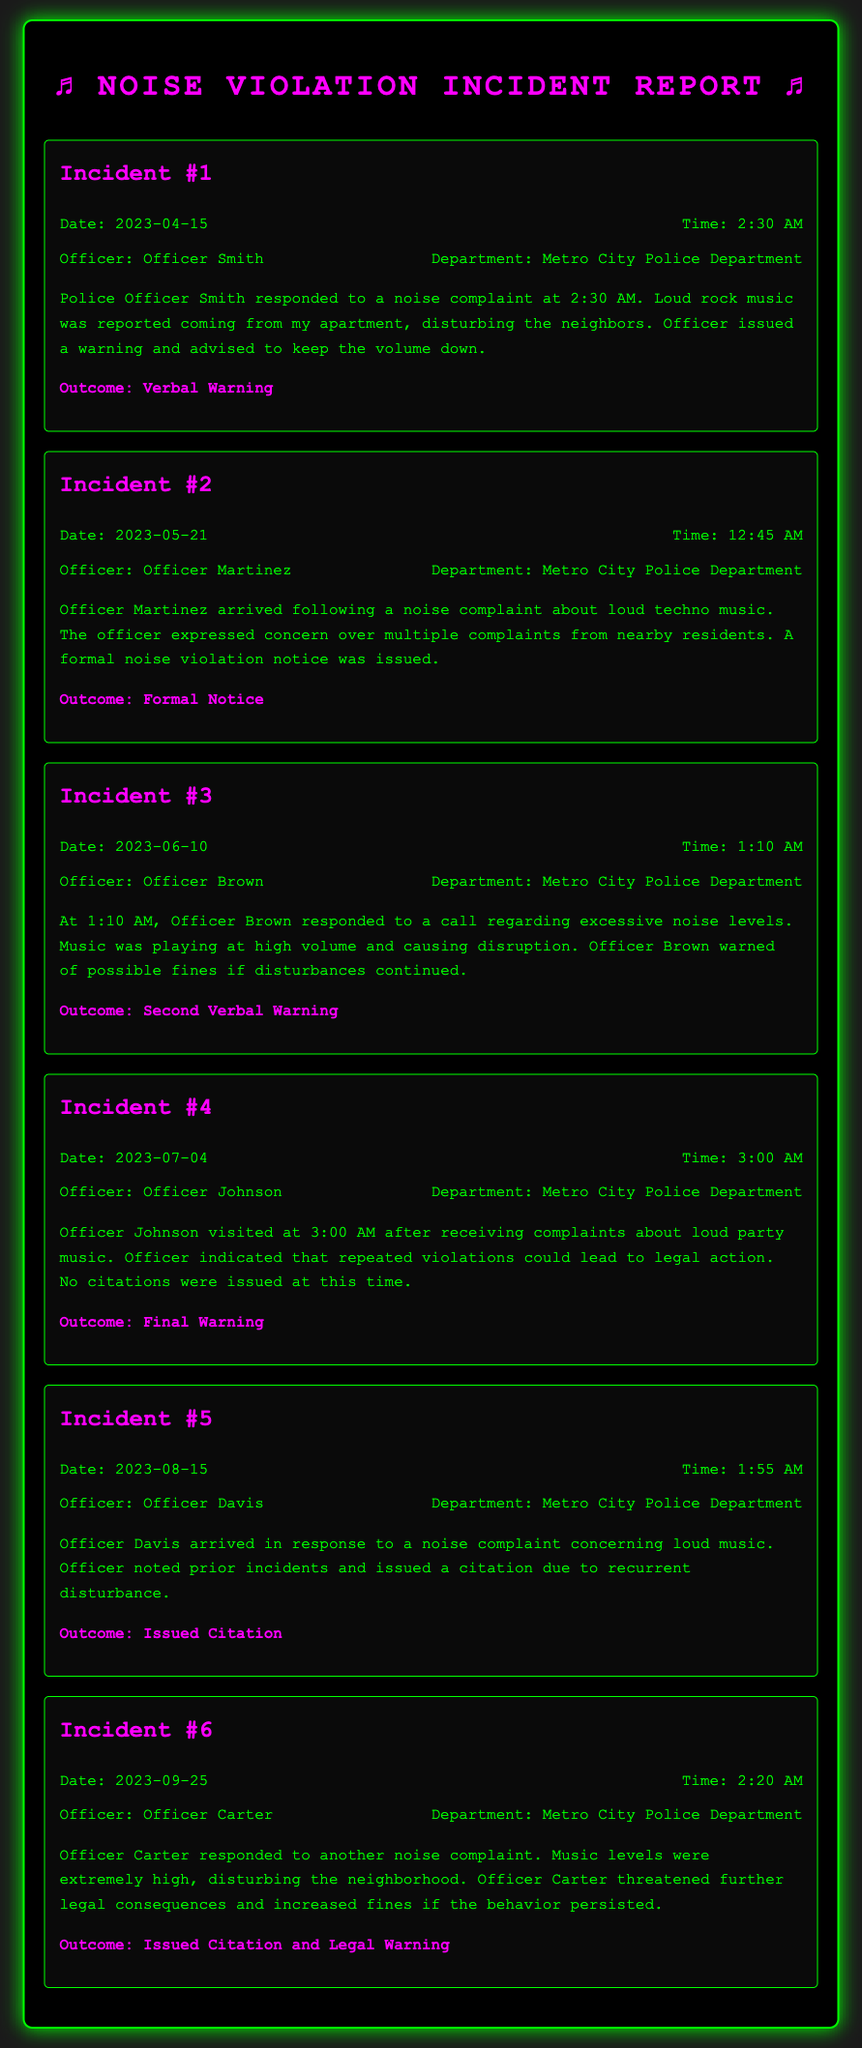what was the date of Incident #3? The date of Incident #3 can be found in the section labeled as "Incident #3," where it is explicitly stated.
Answer: 2023-06-10 who issued a citation during an incident? The citation was issued by Officer Davis, as noted in Incident #5, along with the details concerning prior incidents.
Answer: Officer Davis what time did Officer Martinez respond to the noise complaint? The time can be found in Incident #2 and specifies when Officer Martinez arrived at the scene.
Answer: 12:45 AM how many formal notices were issued throughout the incidents? The document details that only one formal notice was issued in Incident #2.
Answer: 1 which officer responded to the incident on July 4th? The officer's name for the incident on July 4th is mentioned in the details of Incident #4.
Answer: Officer Johnson what was the outcome of Incident #6? The outcome for Incident #6 is specified in the details, indicating the actions taken by Officer Carter.
Answer: Issued Citation and Legal Warning how many total incidents involved police warnings? This can be calculated by reviewing the outcomes listed throughout the incidents, identifying those that included verbal warnings.
Answer: 4 what type of music was reported in the first incident? The type of music is mentioned in the description of Incident #1, revealing what was causing the disturbance.
Answer: loud rock music 